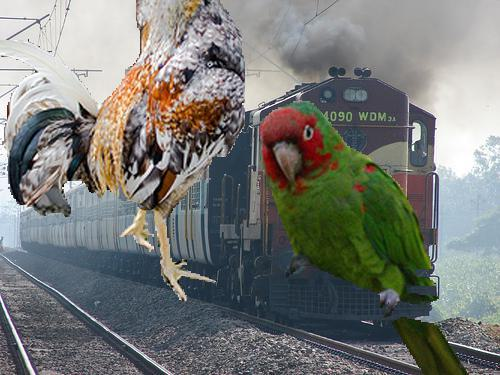Can you create a short story inspired by the surreal composition of this image? Certainly! In a world where dimensions intersect, the 'Express of the Enchanted' rumbled along the tracks, unphased by the curious appearance of gargantuan feathered beings. The emerald parrot, guardian of the forest, and the wise chicken, keeper of the earth's secrets, appeared to send a message. As the engine's whistle cut through the morning mist, they reminded all passengers aboard that while we journey forward, we must always heed the call of the wild and whimsical. 